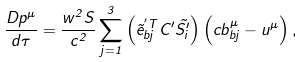<formula> <loc_0><loc_0><loc_500><loc_500>\frac { D p ^ { \mu } } { d \tau } = \frac { w ^ { 2 } S } { c ^ { 2 } } \sum _ { j = 1 } ^ { 3 } \left ( \vec { e } ^ { ^ { \prime } T } _ { b j } C ^ { \prime } \vec { S ^ { \prime } _ { i } } \right ) \left ( c b _ { b j } ^ { \mu } - u ^ { \mu } \right ) ,</formula> 